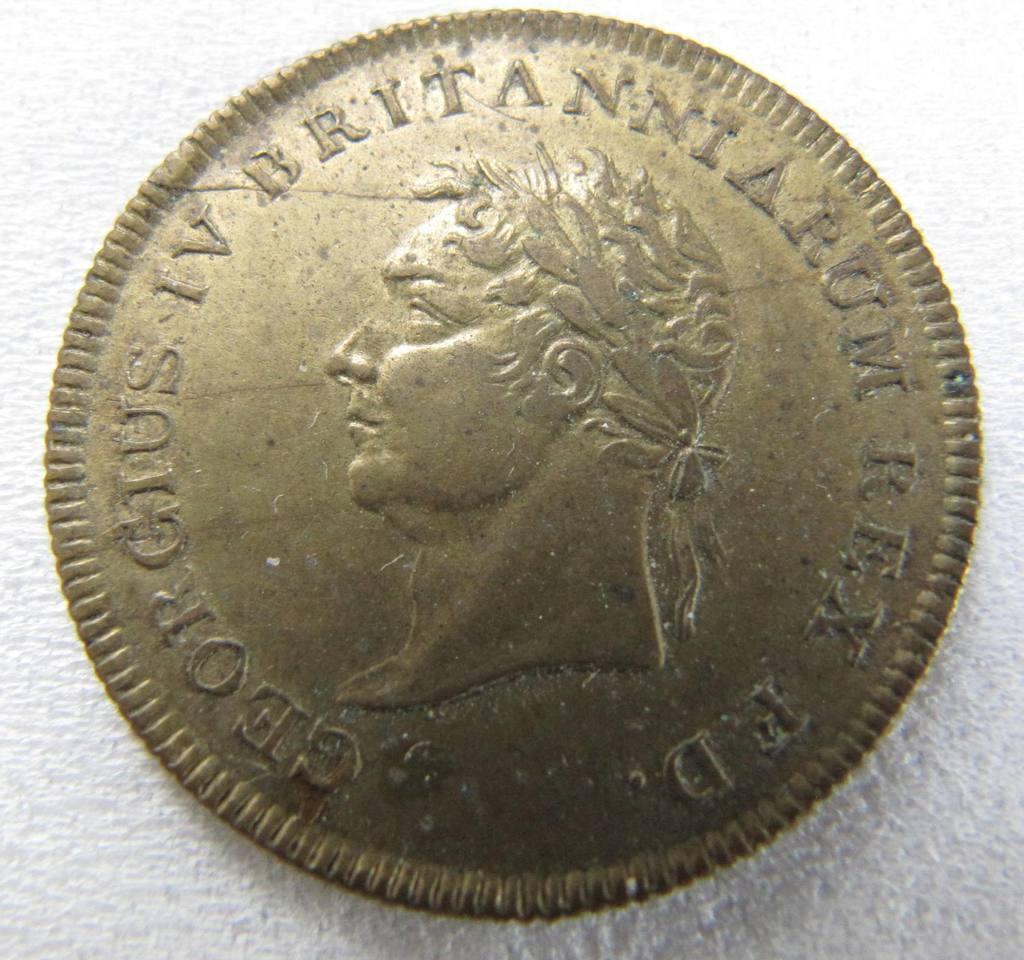Can you describe this image briefly? In this image we can see a coin. 